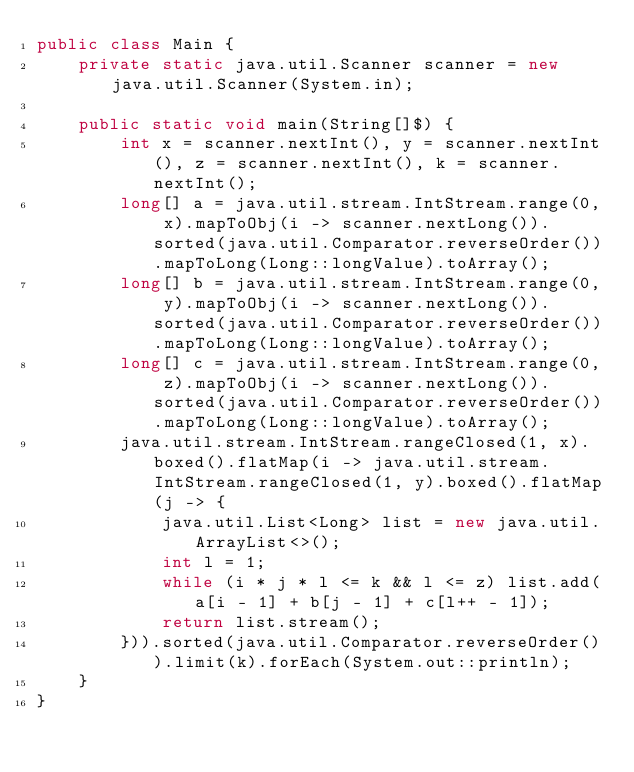Convert code to text. <code><loc_0><loc_0><loc_500><loc_500><_Java_>public class Main {
    private static java.util.Scanner scanner = new java.util.Scanner(System.in);

    public static void main(String[]$) {
        int x = scanner.nextInt(), y = scanner.nextInt(), z = scanner.nextInt(), k = scanner.nextInt();
        long[] a = java.util.stream.IntStream.range(0, x).mapToObj(i -> scanner.nextLong()).sorted(java.util.Comparator.reverseOrder()).mapToLong(Long::longValue).toArray();
        long[] b = java.util.stream.IntStream.range(0, y).mapToObj(i -> scanner.nextLong()).sorted(java.util.Comparator.reverseOrder()).mapToLong(Long::longValue).toArray();
        long[] c = java.util.stream.IntStream.range(0, z).mapToObj(i -> scanner.nextLong()).sorted(java.util.Comparator.reverseOrder()).mapToLong(Long::longValue).toArray();
        java.util.stream.IntStream.rangeClosed(1, x).boxed().flatMap(i -> java.util.stream.IntStream.rangeClosed(1, y).boxed().flatMap(j -> {
            java.util.List<Long> list = new java.util.ArrayList<>();
            int l = 1;
            while (i * j * l <= k && l <= z) list.add(a[i - 1] + b[j - 1] + c[l++ - 1]);
            return list.stream();
        })).sorted(java.util.Comparator.reverseOrder()).limit(k).forEach(System.out::println);
    }
}</code> 